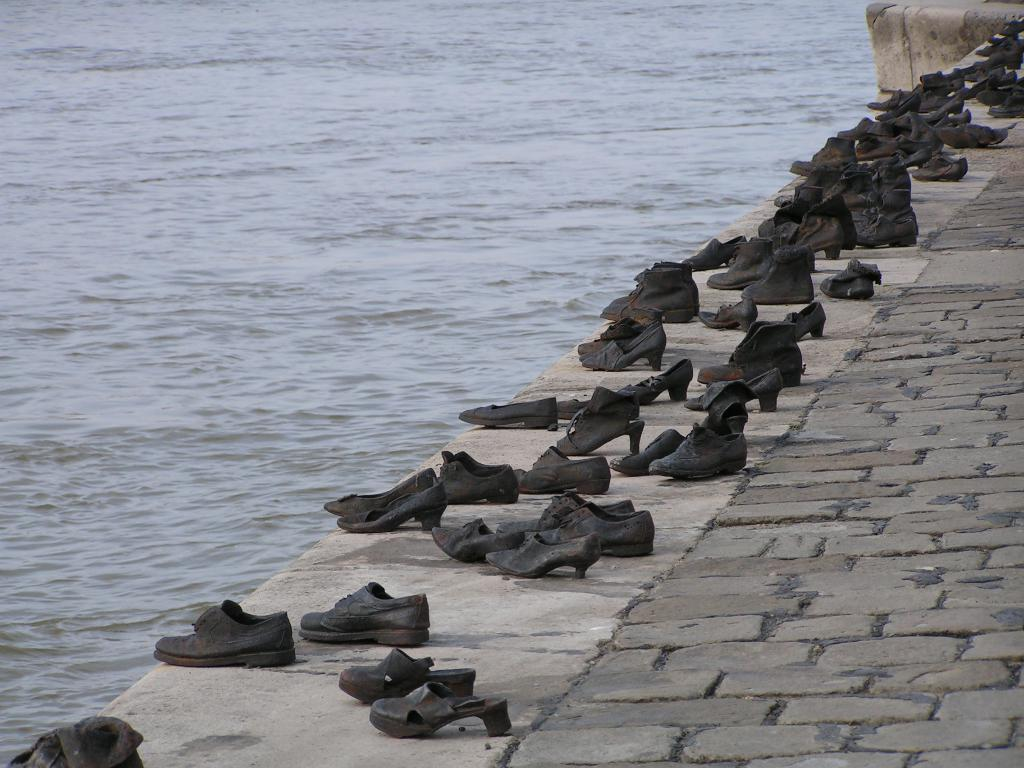What type of footwear can be seen in the image? There are sandals and shoes in the image. What color are the sandals and shoes? The sandals and shoes are black in color. Where are the sandals and shoes located? They are on a pathway. What can be seen at the left side of the image? There is water visible at the left side of the image. What hobbies do the sandals and shoes have in common? Sandals and shoes do not have hobbies, as they are inanimate objects. 